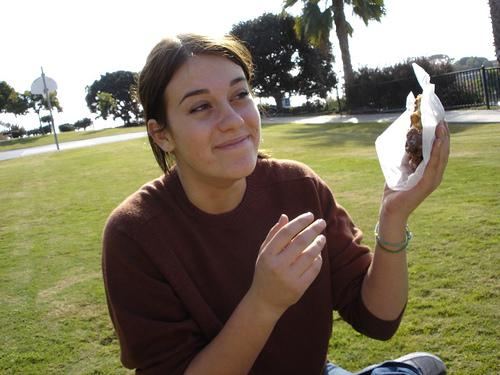Question: what gender is the person?
Choices:
A. Androgynous.
B. Male.
C. Female.
D. Unknown.
Answer with the letter. Answer: C Question: how many people are there?
Choices:
A. Two.
B. Four.
C. Three.
D. One.
Answer with the letter. Answer: D Question: what color is the grass?
Choices:
A. Green.
B. Brown.
C. Amber.
D. Tan.
Answer with the letter. Answer: A Question: when was the picture taken?
Choices:
A. Sunset.
B. 6:48pm.
C. Daytime.
D. Noon.
Answer with the letter. Answer: C Question: where was the picture taken?
Choices:
A. In a car.
B. On a mountain.
C. In a park.
D. On a boat.
Answer with the letter. Answer: C 